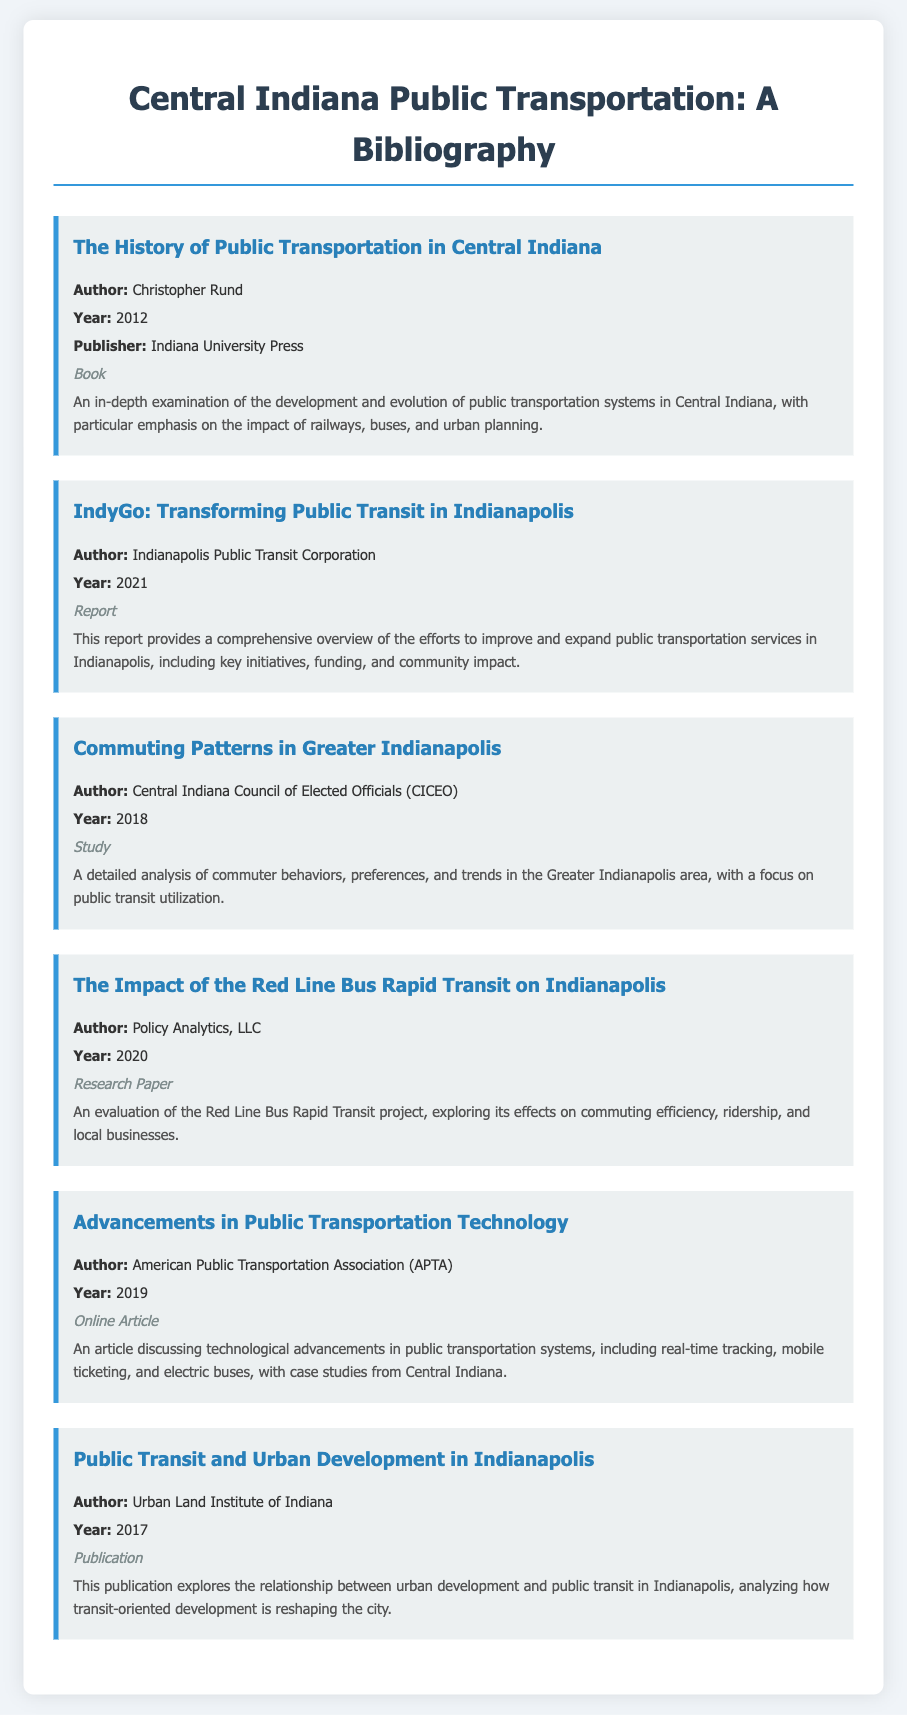What is the title of the first entry? The first entry in the document is titled "The History of Public Transportation in Central Indiana."
Answer: The History of Public Transportation in Central Indiana Who authored the report on IndyGo? The report on IndyGo is authored by the Indianapolis Public Transit Corporation.
Answer: Indianapolis Public Transit Corporation What year was the study on commuting patterns published? The study titled "Commuting Patterns in Greater Indianapolis" was published in 2018.
Answer: 2018 What type of document is "Advancements in Public Transportation Technology"? The document "Advancements in Public Transportation Technology" is classified as an online article.
Answer: Online Article How many entries in total are listed in the bibliography? There are six entries listed in the bibliography.
Answer: Six Who published the book on public transportation history? The book on public transportation history was published by Indiana University Press.
Answer: Indiana University Press What is the primary focus of the publication by the Urban Land Institute of Indiana? The primary focus of the publication is on the relationship between urban development and public transit in Indianapolis.
Answer: Urban development and public transit When was the research paper on the Red Line Bus Rapid Transit published? The research paper on the Red Line Bus Rapid Transit was published in 2020.
Answer: 2020 